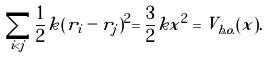Convert formula to latex. <formula><loc_0><loc_0><loc_500><loc_500>\sum _ { i < j } \frac { 1 } { 2 } k ( r _ { i } - r _ { j } ) ^ { 2 } = \frac { 3 } { 2 } k x ^ { 2 } = V _ { h . o . } ( x ) .</formula> 